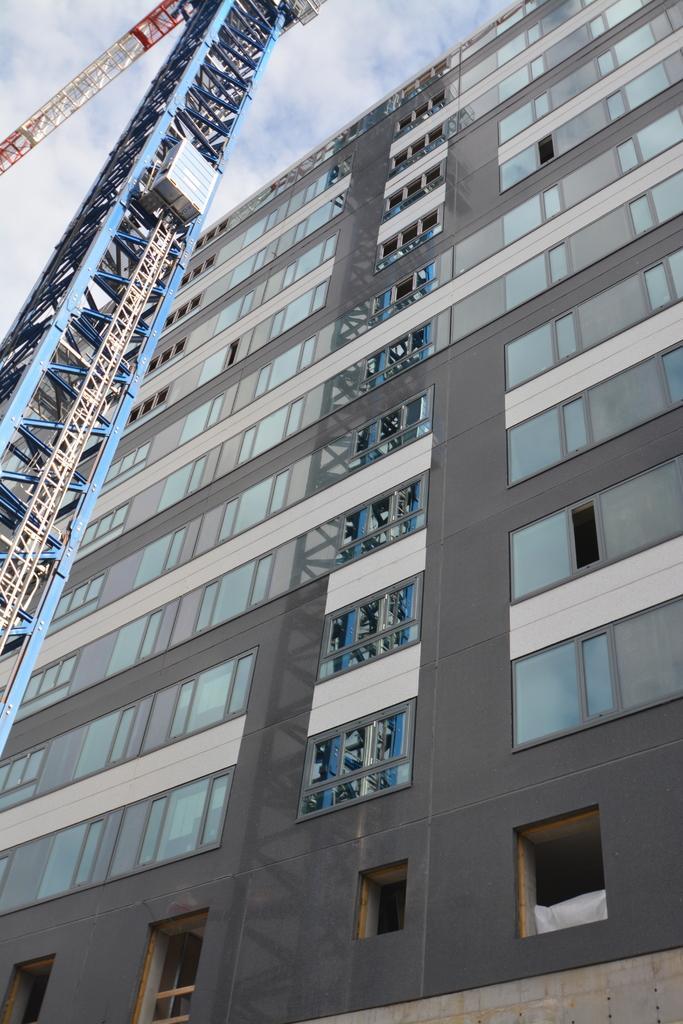Please provide a concise description of this image. In this image, we can see a building and there is a tower. At the top, there are clouds in the sky. 